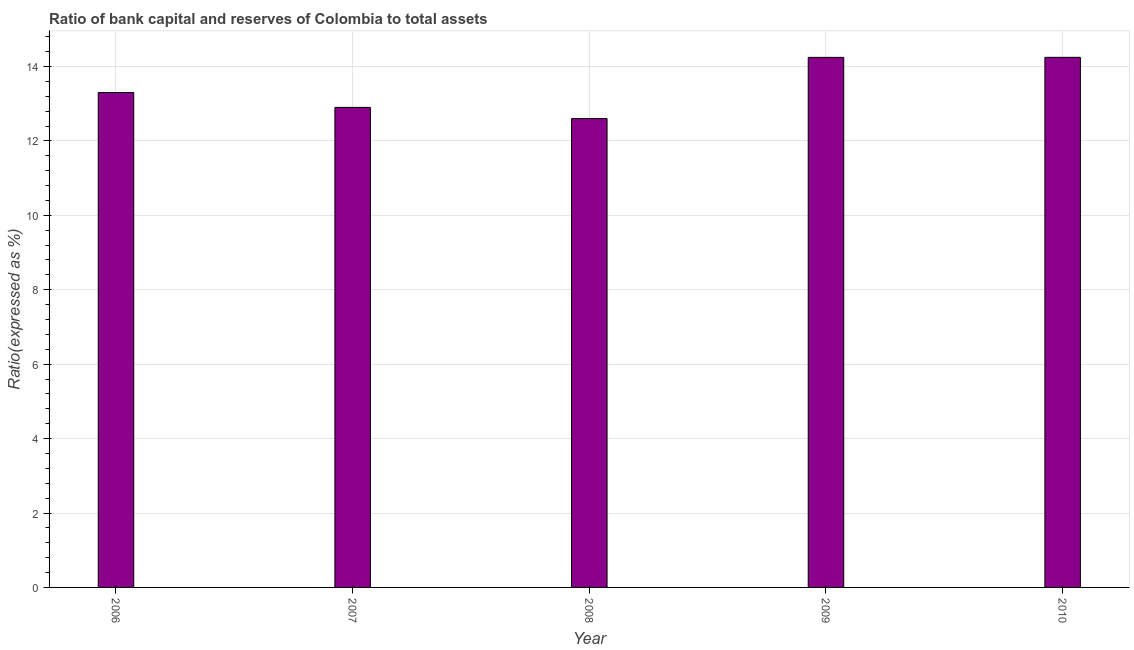What is the title of the graph?
Your answer should be compact. Ratio of bank capital and reserves of Colombia to total assets. What is the label or title of the Y-axis?
Keep it short and to the point. Ratio(expressed as %). What is the bank capital to assets ratio in 2007?
Your response must be concise. 12.9. Across all years, what is the maximum bank capital to assets ratio?
Your answer should be very brief. 14.25. In which year was the bank capital to assets ratio maximum?
Make the answer very short. 2010. What is the sum of the bank capital to assets ratio?
Offer a terse response. 67.29. What is the difference between the bank capital to assets ratio in 2006 and 2010?
Provide a succinct answer. -0.94. What is the average bank capital to assets ratio per year?
Your response must be concise. 13.46. What is the median bank capital to assets ratio?
Keep it short and to the point. 13.3. In how many years, is the bank capital to assets ratio greater than 8.4 %?
Make the answer very short. 5. Do a majority of the years between 2006 and 2007 (inclusive) have bank capital to assets ratio greater than 2 %?
Provide a succinct answer. Yes. What is the ratio of the bank capital to assets ratio in 2006 to that in 2008?
Your answer should be compact. 1.06. Is the bank capital to assets ratio in 2007 less than that in 2010?
Your answer should be very brief. Yes. What is the difference between the highest and the second highest bank capital to assets ratio?
Keep it short and to the point. 0. What is the difference between the highest and the lowest bank capital to assets ratio?
Your response must be concise. 1.65. In how many years, is the bank capital to assets ratio greater than the average bank capital to assets ratio taken over all years?
Keep it short and to the point. 2. What is the Ratio(expressed as %) of 2006?
Give a very brief answer. 13.3. What is the Ratio(expressed as %) in 2009?
Make the answer very short. 14.24. What is the Ratio(expressed as %) of 2010?
Your response must be concise. 14.25. What is the difference between the Ratio(expressed as %) in 2006 and 2009?
Provide a succinct answer. -0.94. What is the difference between the Ratio(expressed as %) in 2006 and 2010?
Your answer should be very brief. -0.95. What is the difference between the Ratio(expressed as %) in 2007 and 2008?
Offer a terse response. 0.3. What is the difference between the Ratio(expressed as %) in 2007 and 2009?
Give a very brief answer. -1.34. What is the difference between the Ratio(expressed as %) in 2007 and 2010?
Ensure brevity in your answer.  -1.35. What is the difference between the Ratio(expressed as %) in 2008 and 2009?
Provide a succinct answer. -1.64. What is the difference between the Ratio(expressed as %) in 2008 and 2010?
Your response must be concise. -1.65. What is the difference between the Ratio(expressed as %) in 2009 and 2010?
Offer a terse response. -0. What is the ratio of the Ratio(expressed as %) in 2006 to that in 2007?
Make the answer very short. 1.03. What is the ratio of the Ratio(expressed as %) in 2006 to that in 2008?
Offer a terse response. 1.06. What is the ratio of the Ratio(expressed as %) in 2006 to that in 2009?
Provide a short and direct response. 0.93. What is the ratio of the Ratio(expressed as %) in 2006 to that in 2010?
Offer a terse response. 0.93. What is the ratio of the Ratio(expressed as %) in 2007 to that in 2008?
Make the answer very short. 1.02. What is the ratio of the Ratio(expressed as %) in 2007 to that in 2009?
Offer a very short reply. 0.91. What is the ratio of the Ratio(expressed as %) in 2007 to that in 2010?
Give a very brief answer. 0.91. What is the ratio of the Ratio(expressed as %) in 2008 to that in 2009?
Offer a very short reply. 0.89. What is the ratio of the Ratio(expressed as %) in 2008 to that in 2010?
Your response must be concise. 0.88. What is the ratio of the Ratio(expressed as %) in 2009 to that in 2010?
Provide a short and direct response. 1. 